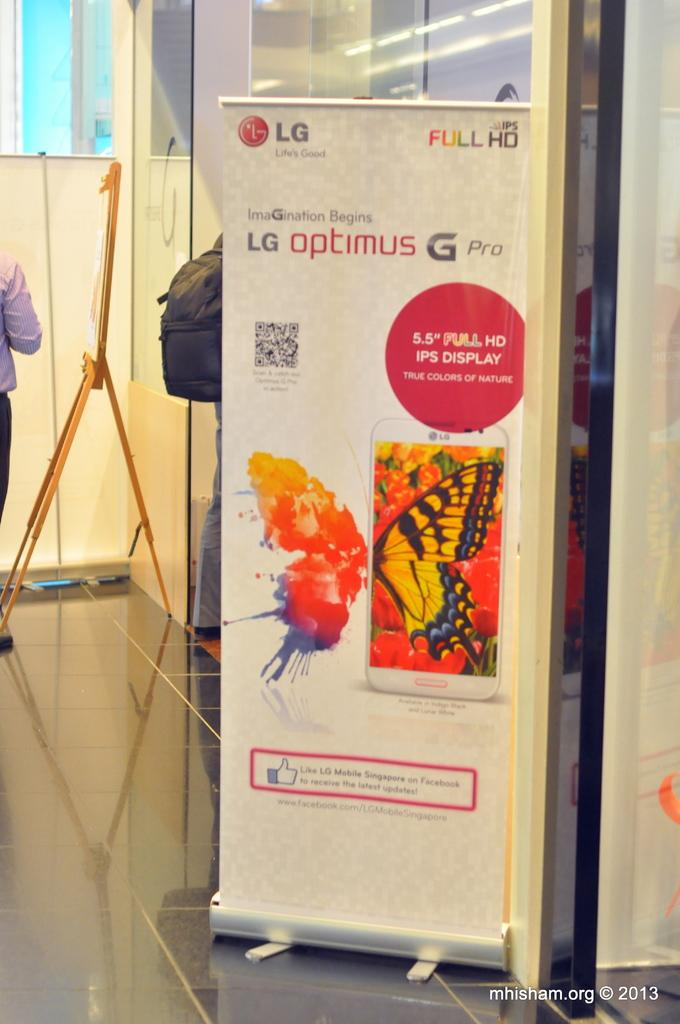<image>
Provide a brief description of the given image. A roll up banner stand advertising the LG Optimus G Pro 